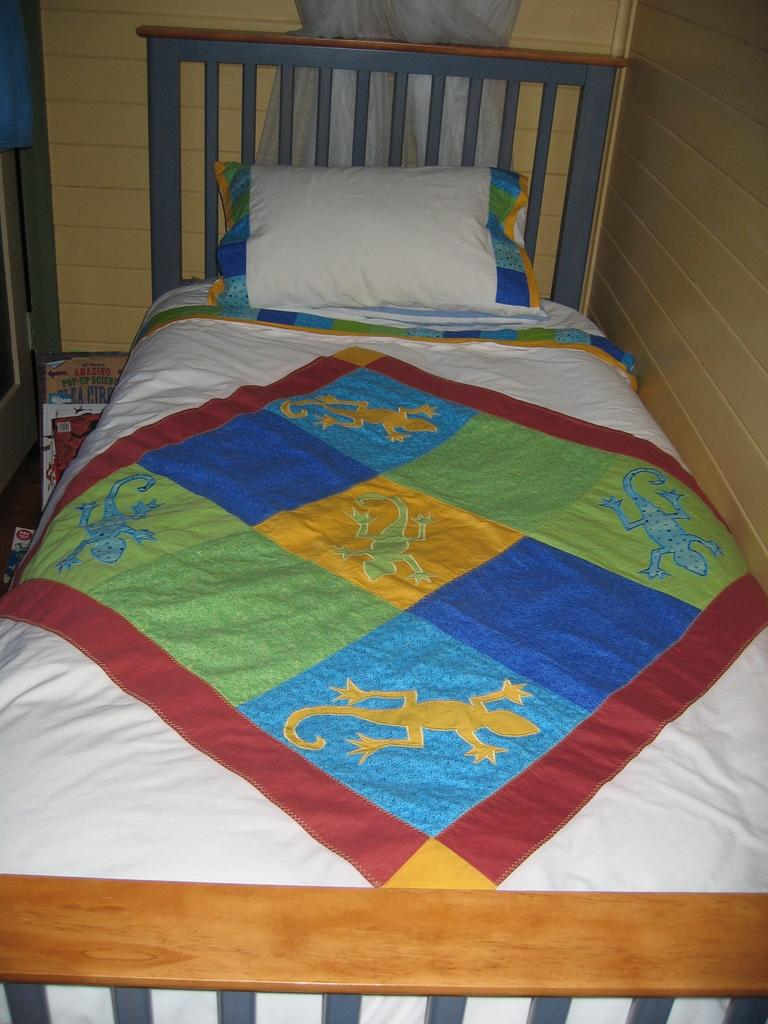What piece of furniture is present in the image? There is a bed in the image. What can be seen on top of the bed? There is a white-colored pillow on the bed. What type of cap is the person wearing in the image? There is no person or cap present in the image; it only features a bed and a white-colored pillow. 